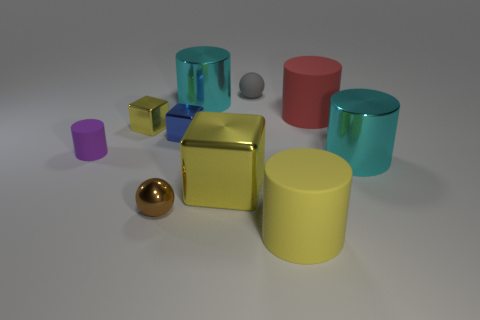Subtract all cyan shiny cylinders. How many cylinders are left? 3 Subtract all yellow cylinders. How many cylinders are left? 4 Subtract 1 cubes. How many cubes are left? 2 Subtract all blocks. How many objects are left? 7 Subtract all yellow blocks. Subtract all blue cylinders. How many blocks are left? 1 Subtract all cyan balls. How many green cylinders are left? 0 Subtract all big cyan matte blocks. Subtract all big cubes. How many objects are left? 9 Add 1 purple matte cylinders. How many purple matte cylinders are left? 2 Add 8 tiny yellow shiny balls. How many tiny yellow shiny balls exist? 8 Subtract 0 red balls. How many objects are left? 10 